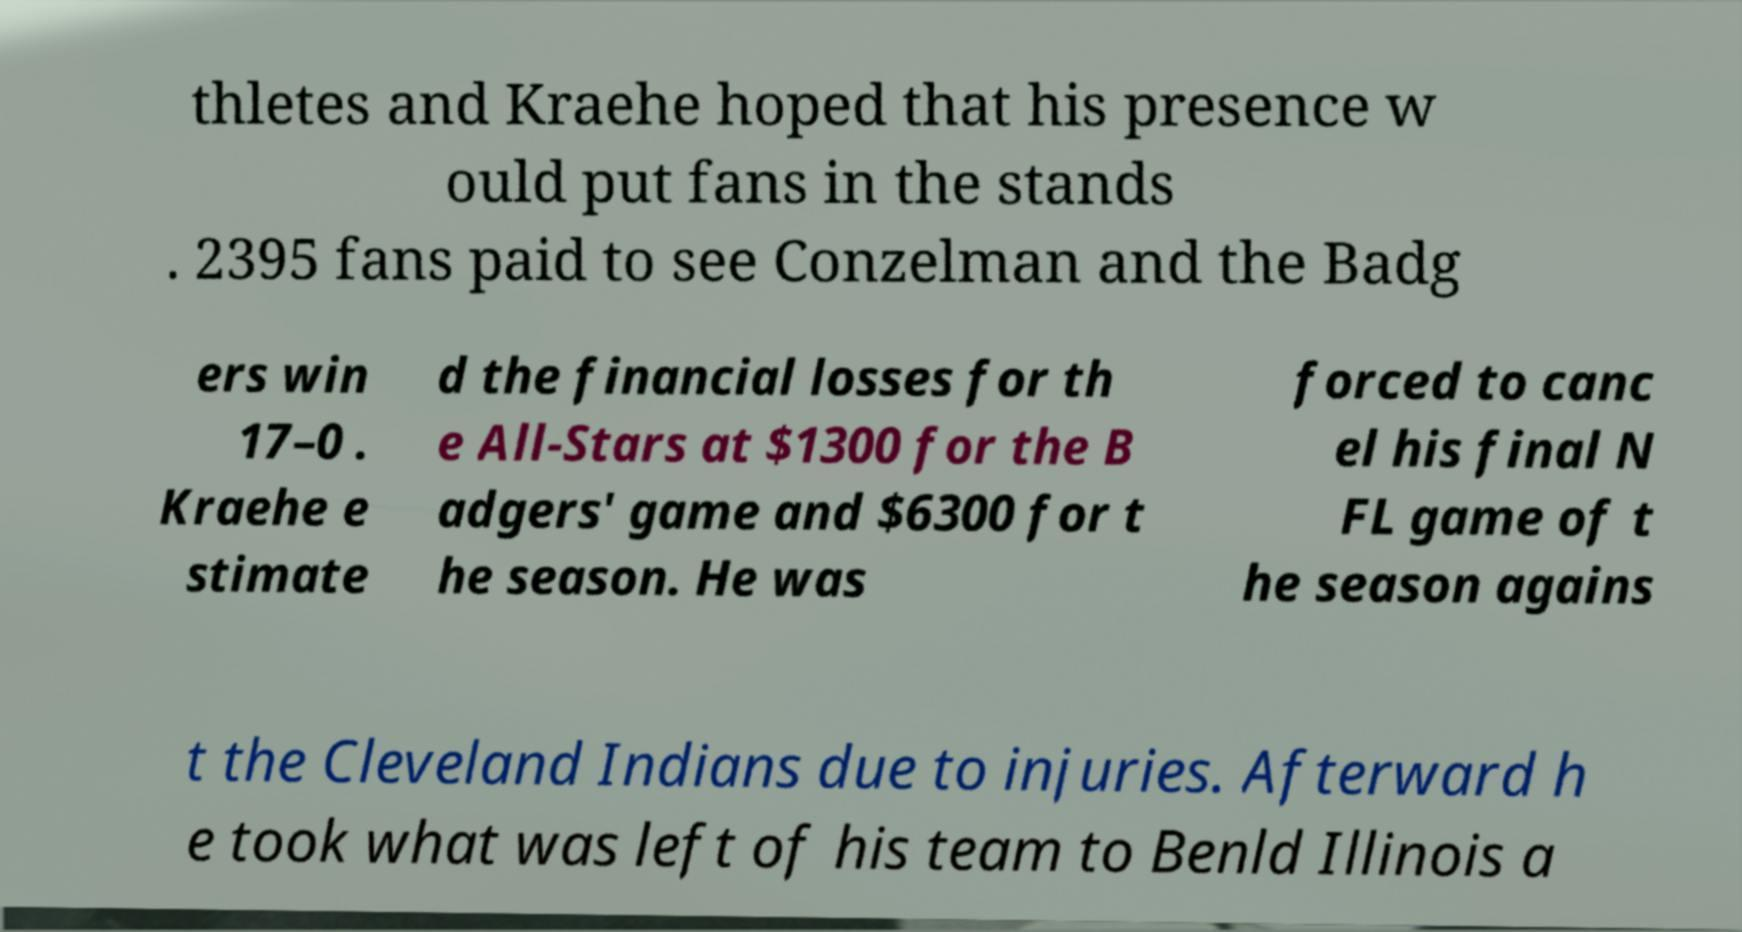Please identify and transcribe the text found in this image. thletes and Kraehe hoped that his presence w ould put fans in the stands . 2395 fans paid to see Conzelman and the Badg ers win 17–0 . Kraehe e stimate d the financial losses for th e All-Stars at $1300 for the B adgers' game and $6300 for t he season. He was forced to canc el his final N FL game of t he season agains t the Cleveland Indians due to injuries. Afterward h e took what was left of his team to Benld Illinois a 